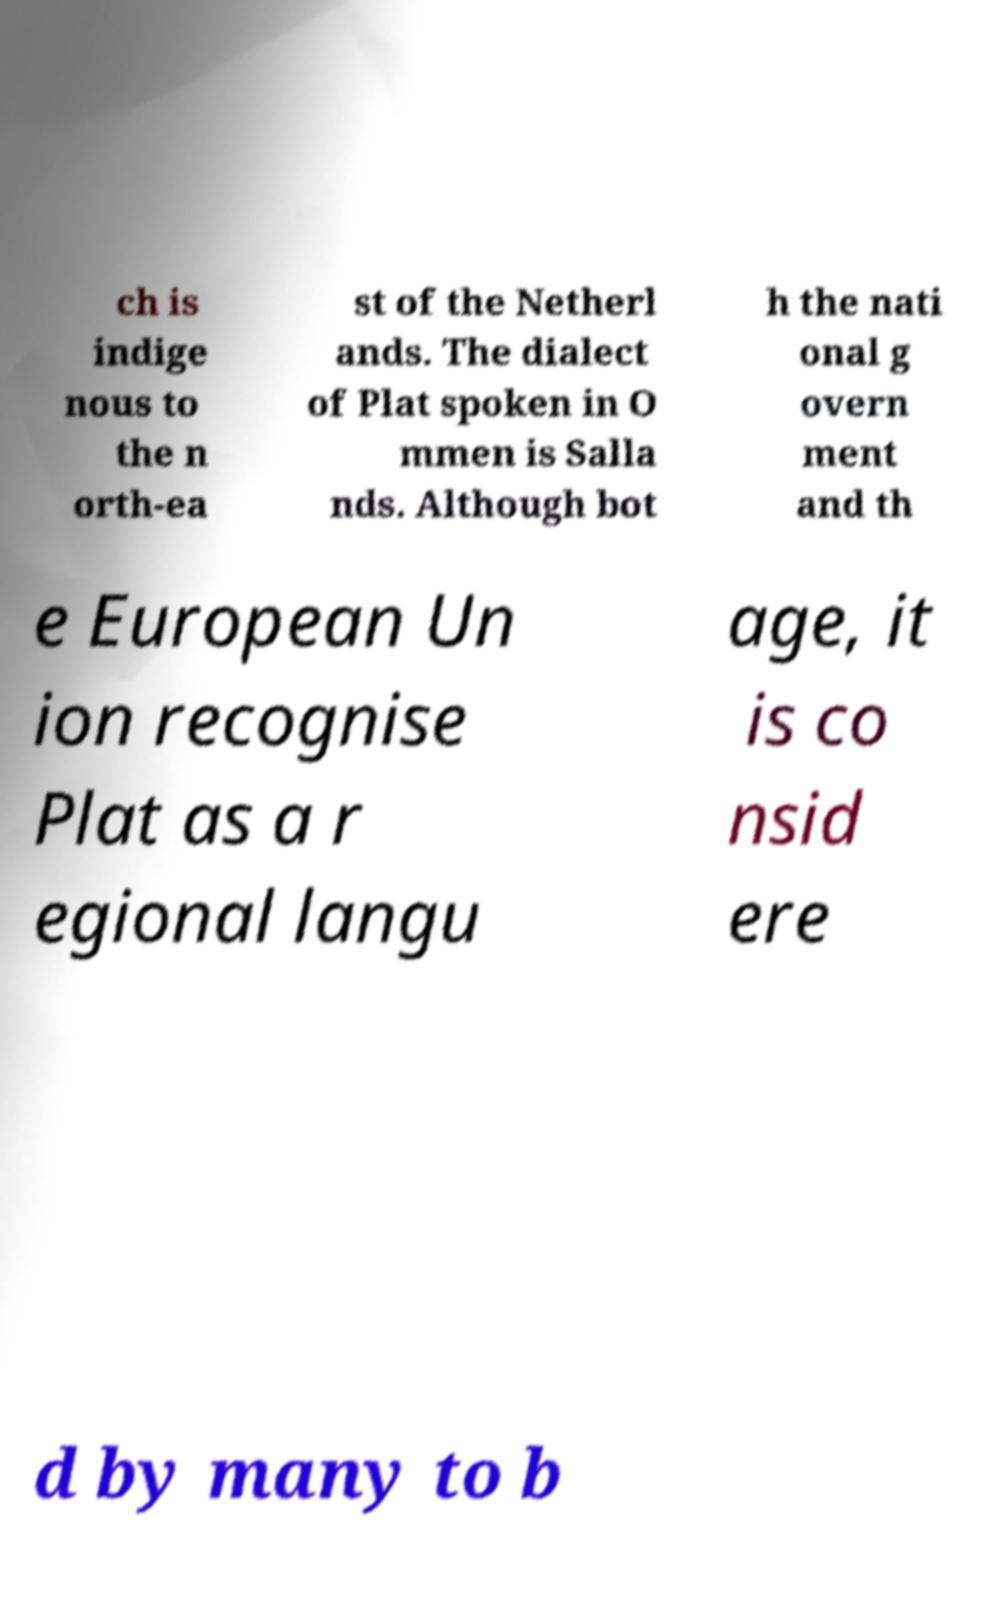Please read and relay the text visible in this image. What does it say? ch is indige nous to the n orth-ea st of the Netherl ands. The dialect of Plat spoken in O mmen is Salla nds. Although bot h the nati onal g overn ment and th e European Un ion recognise Plat as a r egional langu age, it is co nsid ere d by many to b 